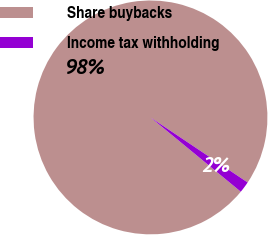<chart> <loc_0><loc_0><loc_500><loc_500><pie_chart><fcel>Share buybacks<fcel>Income tax withholding<nl><fcel>98.43%<fcel>1.57%<nl></chart> 